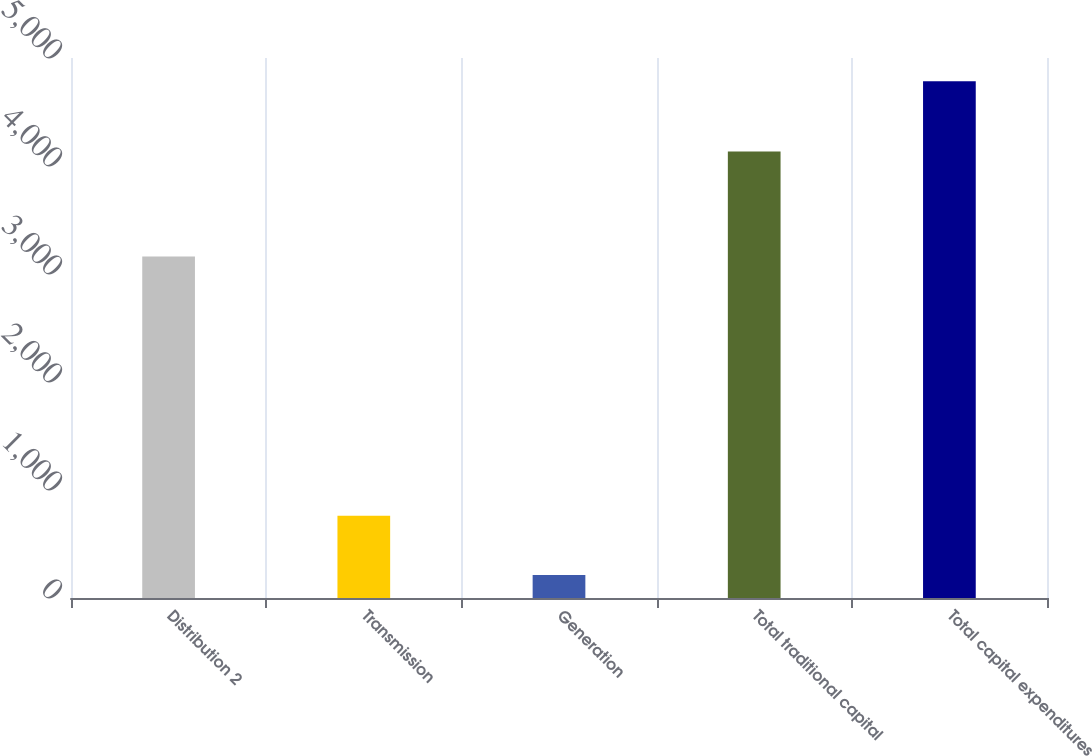<chart> <loc_0><loc_0><loc_500><loc_500><bar_chart><fcel>Distribution 2<fcel>Transmission<fcel>Generation<fcel>Total traditional capital<fcel>Total capital expenditures<nl><fcel>3161<fcel>762<fcel>212<fcel>4135<fcel>4784<nl></chart> 